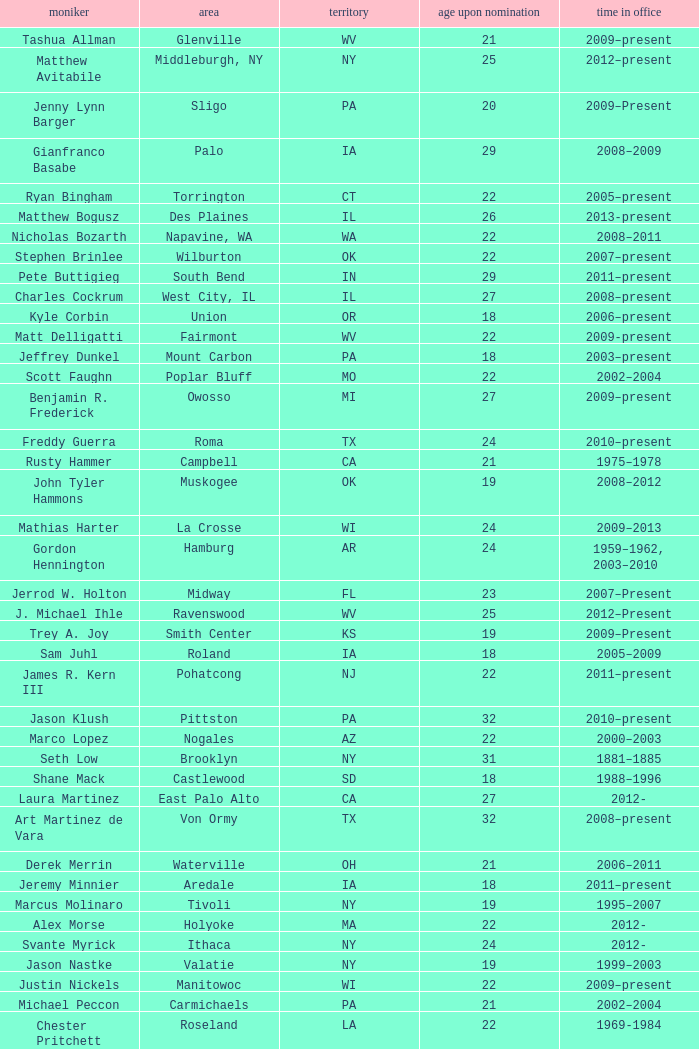What is the name of the holland locale Philip A. Tanis. 